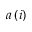Convert formula to latex. <formula><loc_0><loc_0><loc_500><loc_500>a \left ( i \right )</formula> 